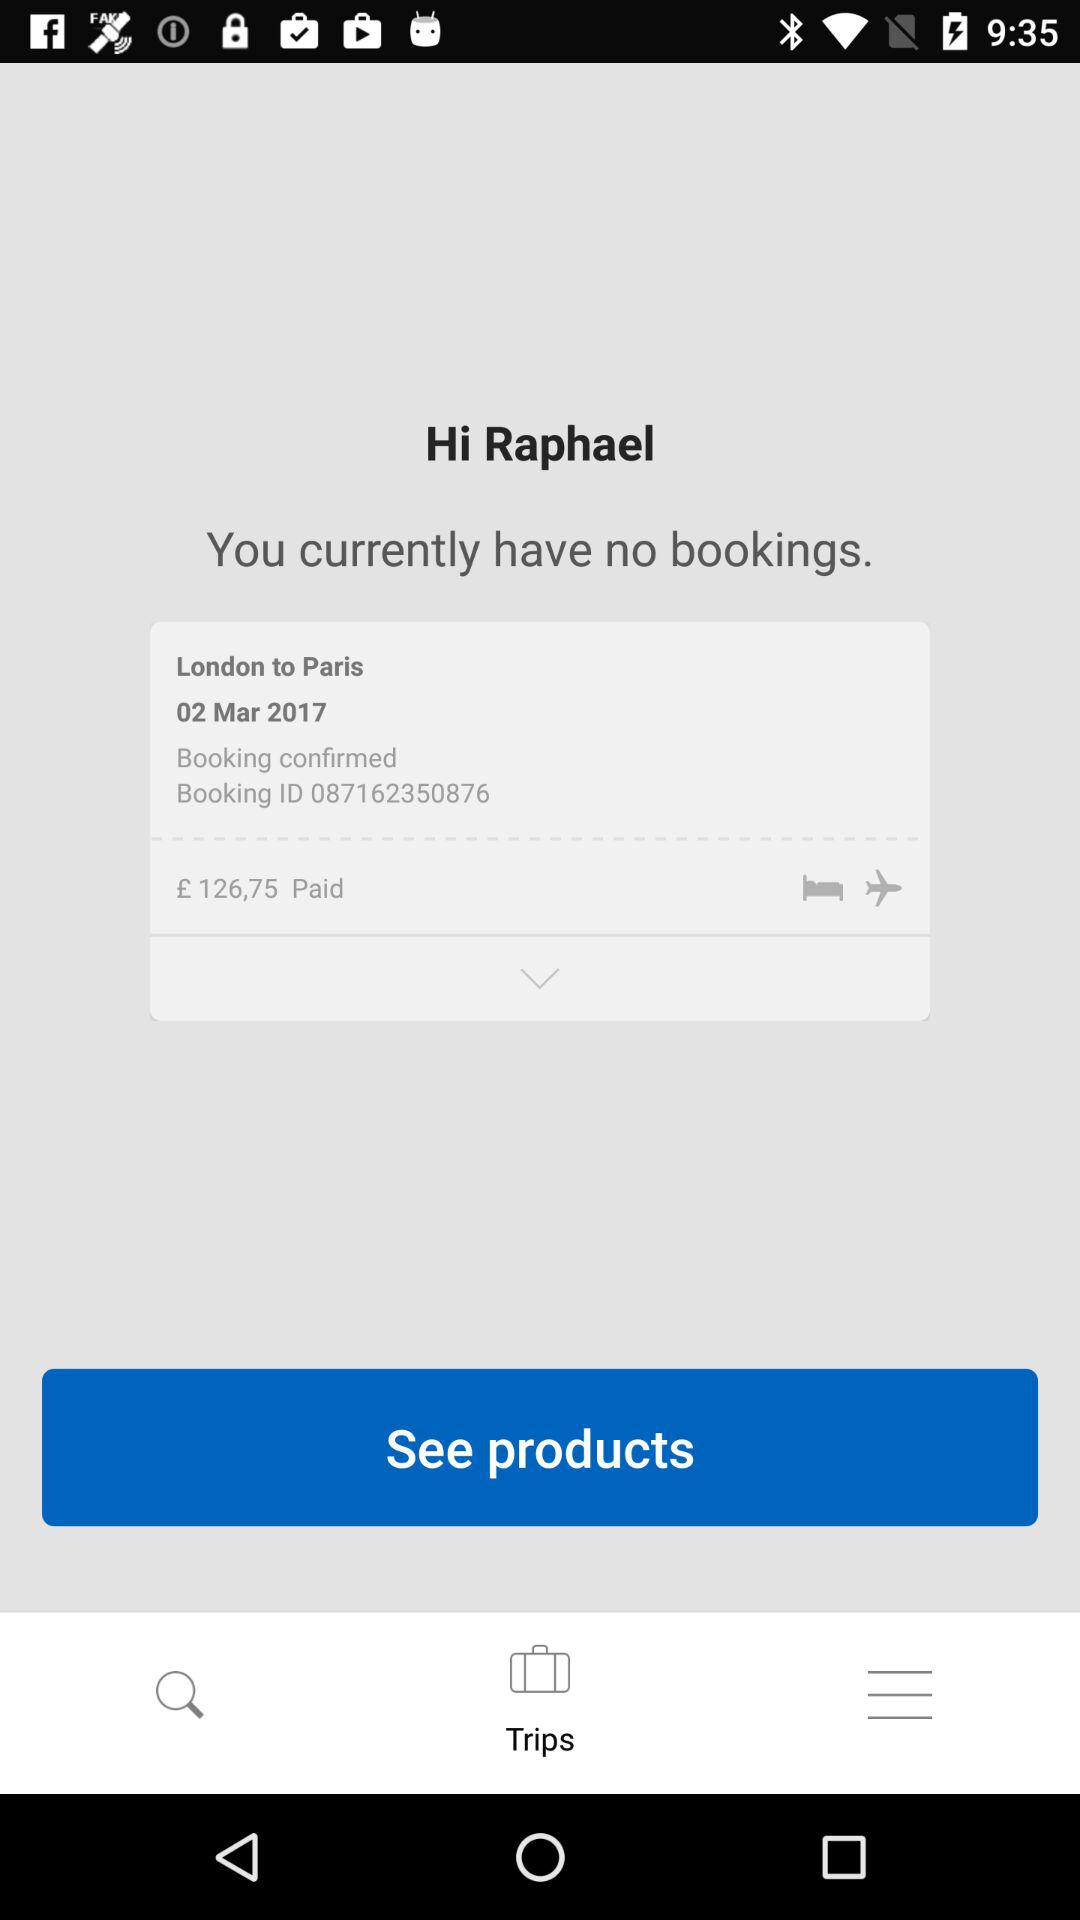What was the destination place? The destination place was Paris. 